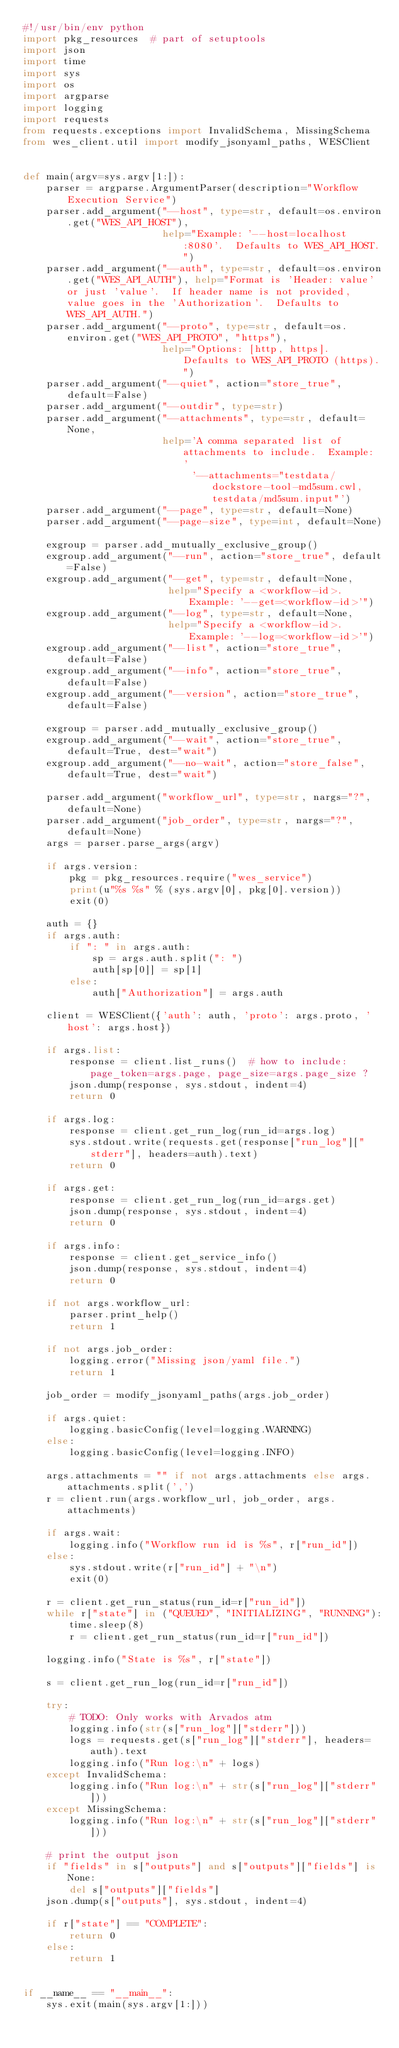<code> <loc_0><loc_0><loc_500><loc_500><_Python_>#!/usr/bin/env python
import pkg_resources  # part of setuptools
import json
import time
import sys
import os
import argparse
import logging
import requests
from requests.exceptions import InvalidSchema, MissingSchema
from wes_client.util import modify_jsonyaml_paths, WESClient


def main(argv=sys.argv[1:]):
    parser = argparse.ArgumentParser(description="Workflow Execution Service")
    parser.add_argument("--host", type=str, default=os.environ.get("WES_API_HOST"),
                        help="Example: '--host=localhost:8080'.  Defaults to WES_API_HOST.")
    parser.add_argument("--auth", type=str, default=os.environ.get("WES_API_AUTH"), help="Format is 'Header: value' or just 'value'.  If header name is not provided, value goes in the 'Authorization'.  Defaults to WES_API_AUTH.")
    parser.add_argument("--proto", type=str, default=os.environ.get("WES_API_PROTO", "https"),
                        help="Options: [http, https].  Defaults to WES_API_PROTO (https).")
    parser.add_argument("--quiet", action="store_true", default=False)
    parser.add_argument("--outdir", type=str)
    parser.add_argument("--attachments", type=str, default=None,
                        help='A comma separated list of attachments to include.  Example: '
                             '--attachments="testdata/dockstore-tool-md5sum.cwl,testdata/md5sum.input"')
    parser.add_argument("--page", type=str, default=None)
    parser.add_argument("--page-size", type=int, default=None)

    exgroup = parser.add_mutually_exclusive_group()
    exgroup.add_argument("--run", action="store_true", default=False)
    exgroup.add_argument("--get", type=str, default=None,
                         help="Specify a <workflow-id>.  Example: '--get=<workflow-id>'")
    exgroup.add_argument("--log", type=str, default=None,
                         help="Specify a <workflow-id>.  Example: '--log=<workflow-id>'")
    exgroup.add_argument("--list", action="store_true", default=False)
    exgroup.add_argument("--info", action="store_true", default=False)
    exgroup.add_argument("--version", action="store_true", default=False)

    exgroup = parser.add_mutually_exclusive_group()
    exgroup.add_argument("--wait", action="store_true", default=True, dest="wait")
    exgroup.add_argument("--no-wait", action="store_false", default=True, dest="wait")

    parser.add_argument("workflow_url", type=str, nargs="?", default=None)
    parser.add_argument("job_order", type=str, nargs="?", default=None)
    args = parser.parse_args(argv)

    if args.version:
        pkg = pkg_resources.require("wes_service")
        print(u"%s %s" % (sys.argv[0], pkg[0].version))
        exit(0)

    auth = {}
    if args.auth:
        if ": " in args.auth:
            sp = args.auth.split(": ")
            auth[sp[0]] = sp[1]
        else:
            auth["Authorization"] = args.auth

    client = WESClient({'auth': auth, 'proto': args.proto, 'host': args.host})

    if args.list:
        response = client.list_runs()  # how to include: page_token=args.page, page_size=args.page_size ?
        json.dump(response, sys.stdout, indent=4)
        return 0

    if args.log:
        response = client.get_run_log(run_id=args.log)
        sys.stdout.write(requests.get(response["run_log"]["stderr"], headers=auth).text)
        return 0

    if args.get:
        response = client.get_run_log(run_id=args.get)
        json.dump(response, sys.stdout, indent=4)
        return 0

    if args.info:
        response = client.get_service_info()
        json.dump(response, sys.stdout, indent=4)
        return 0

    if not args.workflow_url:
        parser.print_help()
        return 1

    if not args.job_order:
        logging.error("Missing json/yaml file.")
        return 1

    job_order = modify_jsonyaml_paths(args.job_order)

    if args.quiet:
        logging.basicConfig(level=logging.WARNING)
    else:
        logging.basicConfig(level=logging.INFO)

    args.attachments = "" if not args.attachments else args.attachments.split(',')
    r = client.run(args.workflow_url, job_order, args.attachments)

    if args.wait:
        logging.info("Workflow run id is %s", r["run_id"])
    else:
        sys.stdout.write(r["run_id"] + "\n")
        exit(0)

    r = client.get_run_status(run_id=r["run_id"])
    while r["state"] in ("QUEUED", "INITIALIZING", "RUNNING"):
        time.sleep(8)
        r = client.get_run_status(run_id=r["run_id"])

    logging.info("State is %s", r["state"])

    s = client.get_run_log(run_id=r["run_id"])

    try:
        # TODO: Only works with Arvados atm
        logging.info(str(s["run_log"]["stderr"]))
        logs = requests.get(s["run_log"]["stderr"], headers=auth).text
        logging.info("Run log:\n" + logs)
    except InvalidSchema:
        logging.info("Run log:\n" + str(s["run_log"]["stderr"]))
    except MissingSchema:
        logging.info("Run log:\n" + str(s["run_log"]["stderr"]))

    # print the output json
    if "fields" in s["outputs"] and s["outputs"]["fields"] is None:
        del s["outputs"]["fields"]
    json.dump(s["outputs"], sys.stdout, indent=4)

    if r["state"] == "COMPLETE":
        return 0
    else:
        return 1


if __name__ == "__main__":
    sys.exit(main(sys.argv[1:]))
</code> 